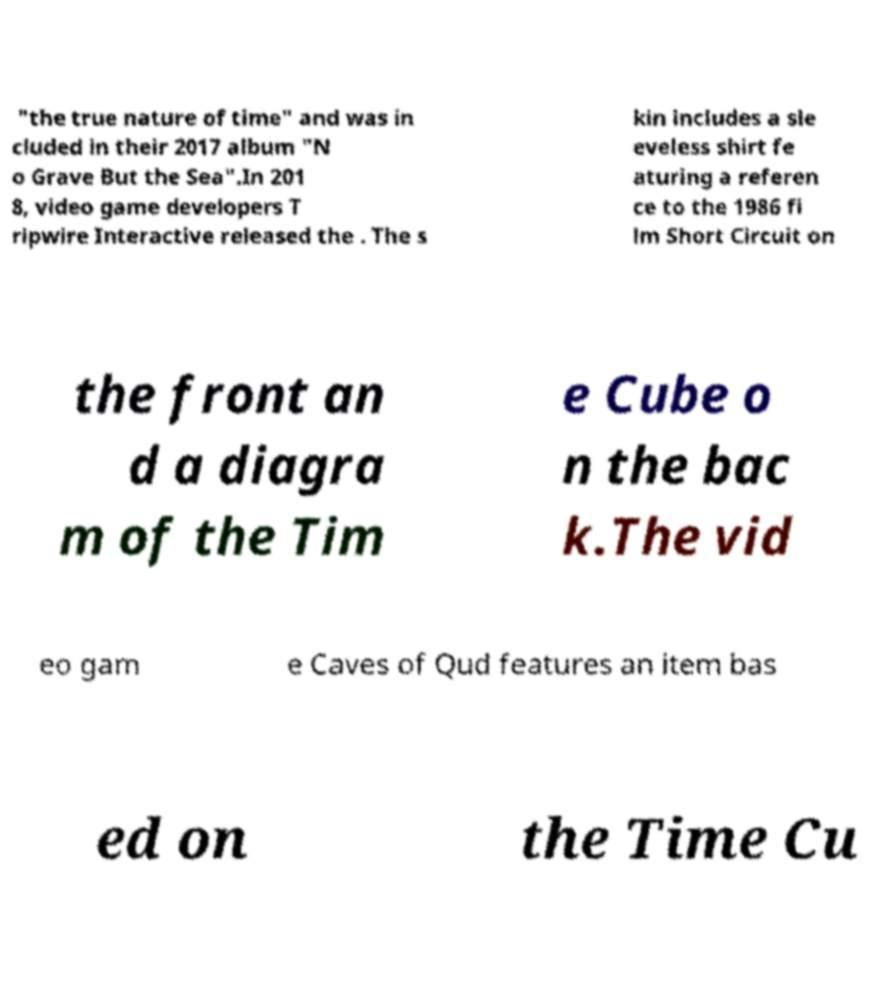Could you extract and type out the text from this image? "the true nature of time" and was in cluded in their 2017 album "N o Grave But the Sea".In 201 8, video game developers T ripwire Interactive released the . The s kin includes a sle eveless shirt fe aturing a referen ce to the 1986 fi lm Short Circuit on the front an d a diagra m of the Tim e Cube o n the bac k.The vid eo gam e Caves of Qud features an item bas ed on the Time Cu 